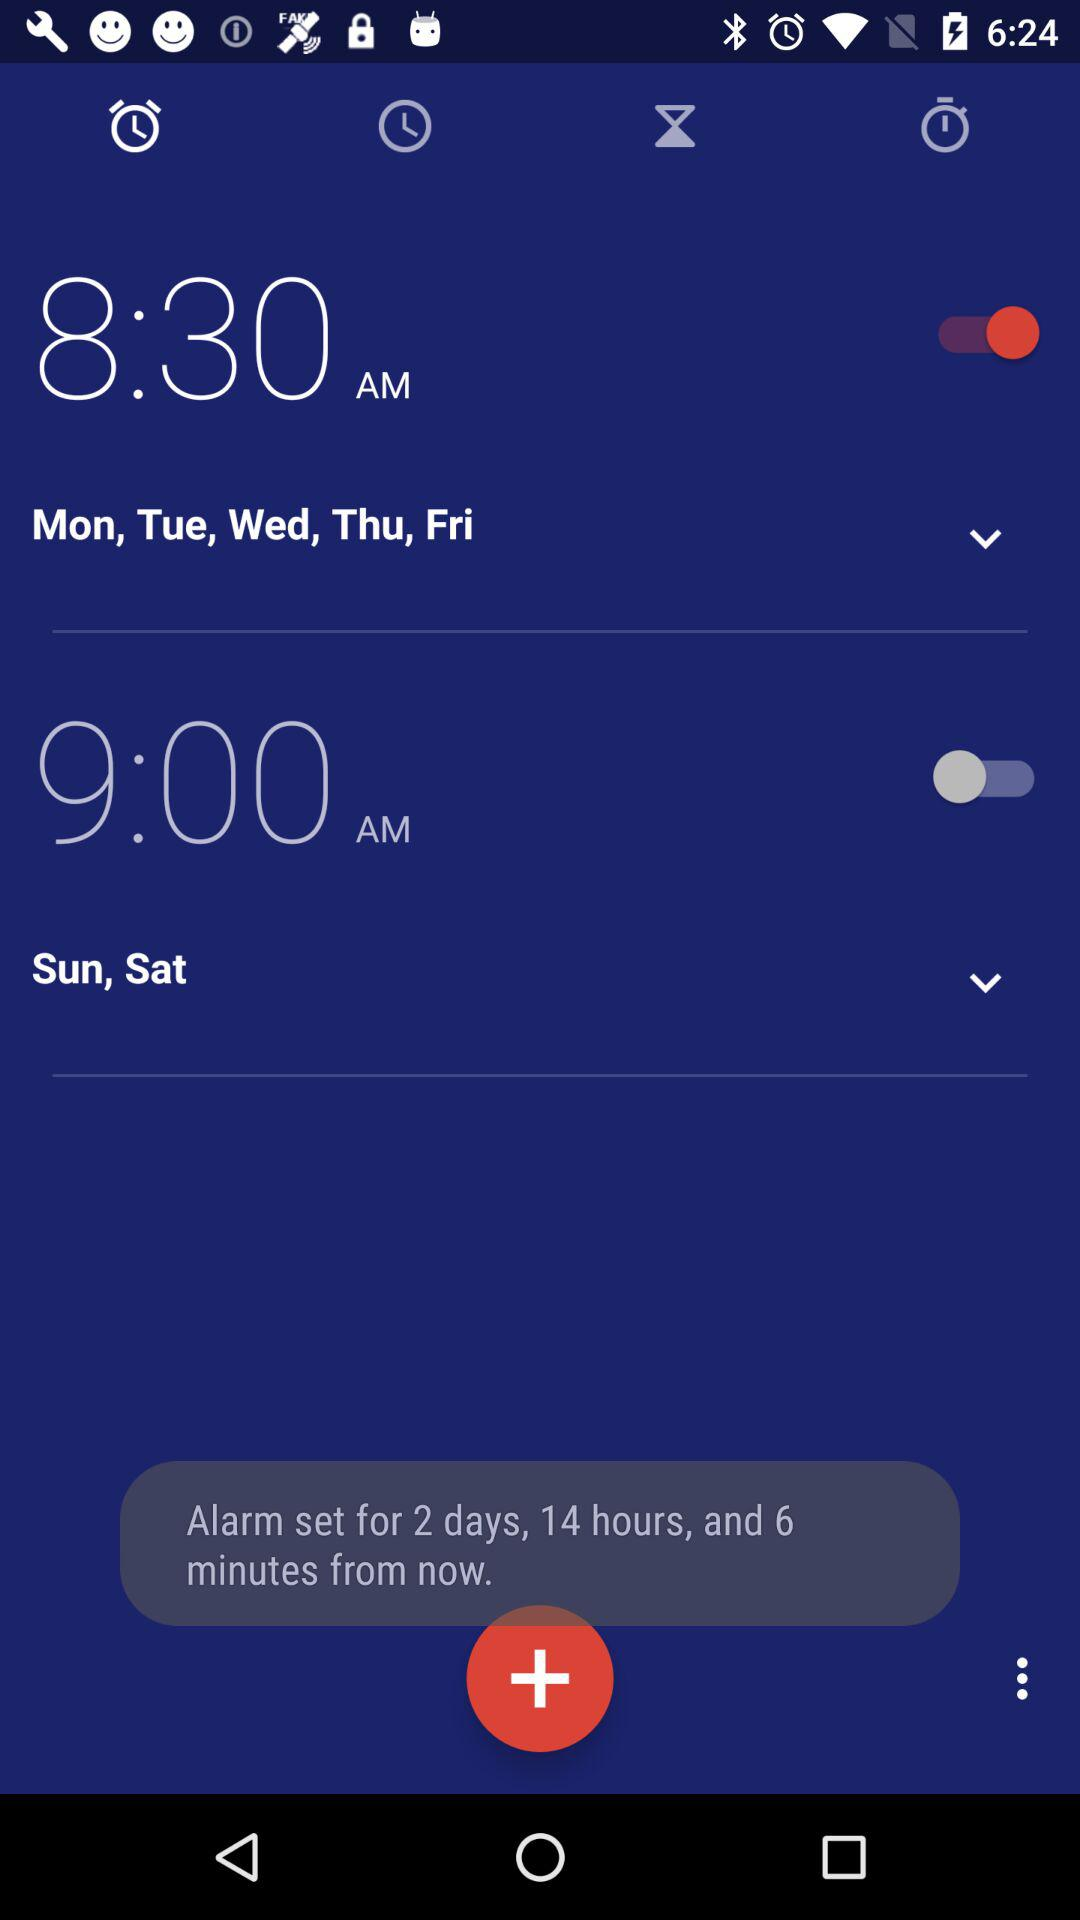For which days is the alarm set for 9 a.m.? The 9 a.m. alarm is set for Saturday and Sunday. 